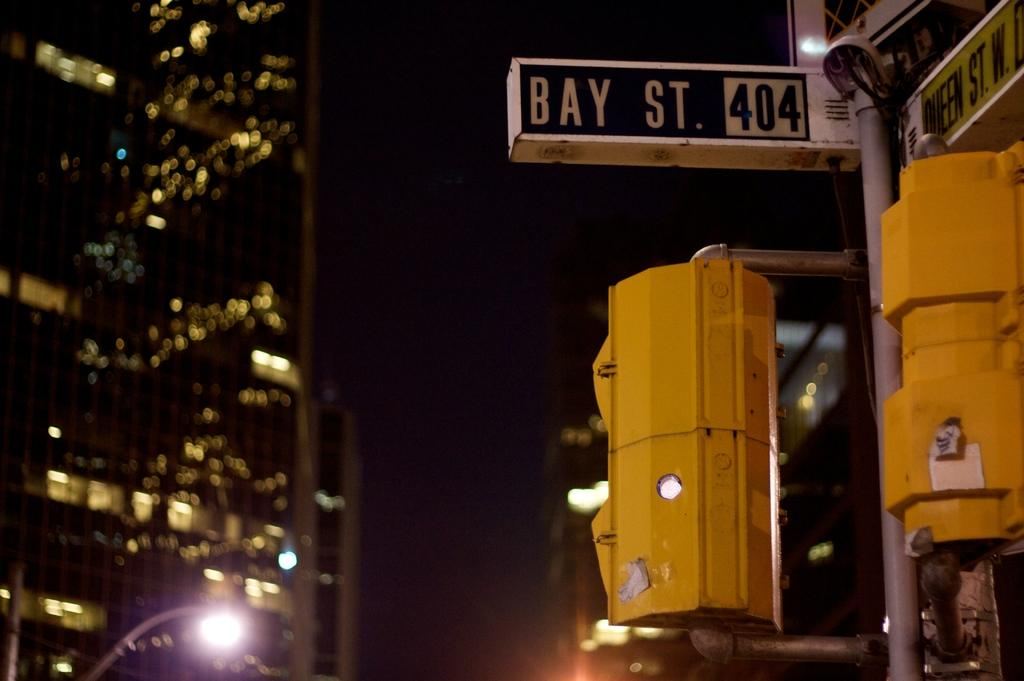What type of structures can be seen in the image? There are buildings in the image. What else is present in the image besides the buildings? There are poles, lights, boxes, and boards with text in the image. What might the poles and lights be used for in the image? The poles and lights might be used for illumination or signage in the image. What information can be gathered from the boards with text in the image? The boards with text in the image might contain information, advertisements, or directions. How would you describe the overall appearance of the image? The background of the image is dark. What type of bells can be heard ringing in the image? There are no bells present in the image, and therefore no sound can be heard. How does the acoustics of the buildings affect the sound of the bells in the image? There are no bells present in the image, so the acoustics of the buildings cannot be assessed in relation to bells. 